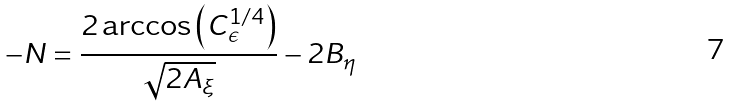Convert formula to latex. <formula><loc_0><loc_0><loc_500><loc_500>- N = \frac { 2 \arccos \left ( C _ { \epsilon } ^ { 1 / 4 } \right ) } { \sqrt { 2 A _ { \xi } } } - 2 B _ { \eta }</formula> 